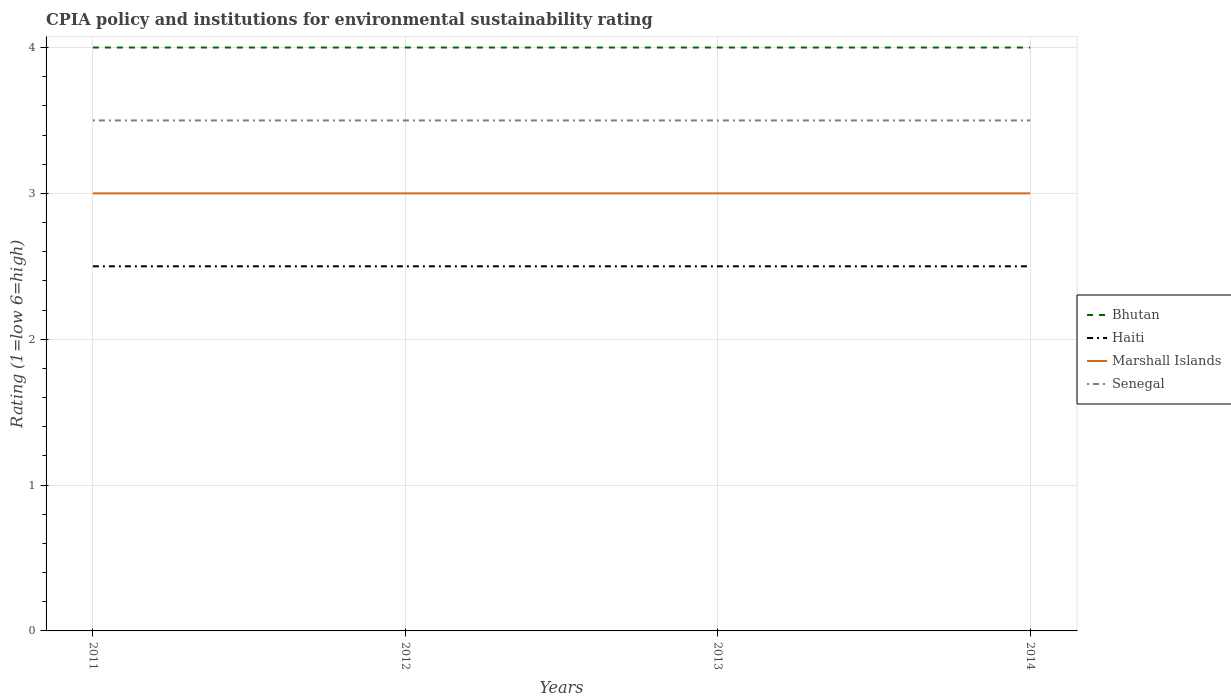How many different coloured lines are there?
Ensure brevity in your answer.  4. In which year was the CPIA rating in Haiti maximum?
Your response must be concise. 2011. What is the difference between the highest and the second highest CPIA rating in Marshall Islands?
Offer a very short reply. 0. What is the difference between two consecutive major ticks on the Y-axis?
Offer a terse response. 1. Does the graph contain any zero values?
Make the answer very short. No. Where does the legend appear in the graph?
Ensure brevity in your answer.  Center right. How many legend labels are there?
Offer a terse response. 4. How are the legend labels stacked?
Provide a short and direct response. Vertical. What is the title of the graph?
Provide a succinct answer. CPIA policy and institutions for environmental sustainability rating. Does "United States" appear as one of the legend labels in the graph?
Ensure brevity in your answer.  No. What is the label or title of the X-axis?
Your response must be concise. Years. What is the label or title of the Y-axis?
Offer a very short reply. Rating (1=low 6=high). What is the Rating (1=low 6=high) in Haiti in 2011?
Keep it short and to the point. 2.5. What is the Rating (1=low 6=high) of Senegal in 2011?
Your answer should be very brief. 3.5. What is the Rating (1=low 6=high) of Marshall Islands in 2012?
Your response must be concise. 3. What is the Rating (1=low 6=high) in Bhutan in 2014?
Keep it short and to the point. 4. What is the Rating (1=low 6=high) in Haiti in 2014?
Keep it short and to the point. 2.5. What is the Rating (1=low 6=high) of Marshall Islands in 2014?
Offer a terse response. 3. Across all years, what is the minimum Rating (1=low 6=high) in Bhutan?
Your response must be concise. 4. Across all years, what is the minimum Rating (1=low 6=high) in Haiti?
Give a very brief answer. 2.5. Across all years, what is the minimum Rating (1=low 6=high) in Senegal?
Provide a short and direct response. 3.5. What is the total Rating (1=low 6=high) in Bhutan in the graph?
Offer a very short reply. 16. What is the total Rating (1=low 6=high) of Haiti in the graph?
Your answer should be very brief. 10. What is the difference between the Rating (1=low 6=high) in Bhutan in 2011 and that in 2012?
Keep it short and to the point. 0. What is the difference between the Rating (1=low 6=high) of Haiti in 2011 and that in 2012?
Offer a very short reply. 0. What is the difference between the Rating (1=low 6=high) of Marshall Islands in 2011 and that in 2012?
Ensure brevity in your answer.  0. What is the difference between the Rating (1=low 6=high) of Senegal in 2011 and that in 2012?
Your response must be concise. 0. What is the difference between the Rating (1=low 6=high) of Haiti in 2011 and that in 2013?
Your answer should be very brief. 0. What is the difference between the Rating (1=low 6=high) of Bhutan in 2011 and that in 2014?
Ensure brevity in your answer.  0. What is the difference between the Rating (1=low 6=high) in Marshall Islands in 2011 and that in 2014?
Give a very brief answer. 0. What is the difference between the Rating (1=low 6=high) in Marshall Islands in 2012 and that in 2013?
Keep it short and to the point. 0. What is the difference between the Rating (1=low 6=high) in Marshall Islands in 2012 and that in 2014?
Your response must be concise. 0. What is the difference between the Rating (1=low 6=high) of Senegal in 2012 and that in 2014?
Provide a short and direct response. 0. What is the difference between the Rating (1=low 6=high) of Bhutan in 2013 and that in 2014?
Your answer should be very brief. 0. What is the difference between the Rating (1=low 6=high) of Bhutan in 2011 and the Rating (1=low 6=high) of Haiti in 2012?
Make the answer very short. 1.5. What is the difference between the Rating (1=low 6=high) of Haiti in 2011 and the Rating (1=low 6=high) of Marshall Islands in 2012?
Keep it short and to the point. -0.5. What is the difference between the Rating (1=low 6=high) of Marshall Islands in 2011 and the Rating (1=low 6=high) of Senegal in 2012?
Provide a short and direct response. -0.5. What is the difference between the Rating (1=low 6=high) of Bhutan in 2011 and the Rating (1=low 6=high) of Marshall Islands in 2013?
Your response must be concise. 1. What is the difference between the Rating (1=low 6=high) in Haiti in 2011 and the Rating (1=low 6=high) in Marshall Islands in 2013?
Your answer should be compact. -0.5. What is the difference between the Rating (1=low 6=high) in Bhutan in 2011 and the Rating (1=low 6=high) in Haiti in 2014?
Offer a very short reply. 1.5. What is the difference between the Rating (1=low 6=high) of Bhutan in 2011 and the Rating (1=low 6=high) of Marshall Islands in 2014?
Your answer should be very brief. 1. What is the difference between the Rating (1=low 6=high) in Bhutan in 2011 and the Rating (1=low 6=high) in Senegal in 2014?
Provide a short and direct response. 0.5. What is the difference between the Rating (1=low 6=high) in Haiti in 2011 and the Rating (1=low 6=high) in Senegal in 2014?
Offer a very short reply. -1. What is the difference between the Rating (1=low 6=high) in Bhutan in 2012 and the Rating (1=low 6=high) in Senegal in 2013?
Offer a very short reply. 0.5. What is the difference between the Rating (1=low 6=high) of Marshall Islands in 2012 and the Rating (1=low 6=high) of Senegal in 2013?
Keep it short and to the point. -0.5. What is the difference between the Rating (1=low 6=high) in Bhutan in 2012 and the Rating (1=low 6=high) in Haiti in 2014?
Offer a terse response. 1.5. What is the difference between the Rating (1=low 6=high) of Bhutan in 2012 and the Rating (1=low 6=high) of Marshall Islands in 2014?
Ensure brevity in your answer.  1. What is the difference between the Rating (1=low 6=high) in Bhutan in 2012 and the Rating (1=low 6=high) in Senegal in 2014?
Ensure brevity in your answer.  0.5. What is the difference between the Rating (1=low 6=high) in Haiti in 2012 and the Rating (1=low 6=high) in Marshall Islands in 2014?
Your answer should be compact. -0.5. What is the difference between the Rating (1=low 6=high) in Haiti in 2012 and the Rating (1=low 6=high) in Senegal in 2014?
Your answer should be compact. -1. What is the difference between the Rating (1=low 6=high) in Marshall Islands in 2012 and the Rating (1=low 6=high) in Senegal in 2014?
Your answer should be compact. -0.5. What is the difference between the Rating (1=low 6=high) in Bhutan in 2013 and the Rating (1=low 6=high) in Haiti in 2014?
Provide a short and direct response. 1.5. What is the difference between the Rating (1=low 6=high) in Haiti in 2013 and the Rating (1=low 6=high) in Marshall Islands in 2014?
Provide a short and direct response. -0.5. What is the difference between the Rating (1=low 6=high) of Haiti in 2013 and the Rating (1=low 6=high) of Senegal in 2014?
Provide a short and direct response. -1. What is the difference between the Rating (1=low 6=high) in Marshall Islands in 2013 and the Rating (1=low 6=high) in Senegal in 2014?
Give a very brief answer. -0.5. What is the average Rating (1=low 6=high) of Marshall Islands per year?
Provide a succinct answer. 3. What is the average Rating (1=low 6=high) in Senegal per year?
Offer a terse response. 3.5. In the year 2011, what is the difference between the Rating (1=low 6=high) in Bhutan and Rating (1=low 6=high) in Haiti?
Your answer should be compact. 1.5. In the year 2011, what is the difference between the Rating (1=low 6=high) in Haiti and Rating (1=low 6=high) in Senegal?
Provide a short and direct response. -1. In the year 2011, what is the difference between the Rating (1=low 6=high) in Marshall Islands and Rating (1=low 6=high) in Senegal?
Your answer should be very brief. -0.5. In the year 2012, what is the difference between the Rating (1=low 6=high) in Bhutan and Rating (1=low 6=high) in Haiti?
Keep it short and to the point. 1.5. In the year 2012, what is the difference between the Rating (1=low 6=high) of Haiti and Rating (1=low 6=high) of Marshall Islands?
Offer a terse response. -0.5. In the year 2012, what is the difference between the Rating (1=low 6=high) of Marshall Islands and Rating (1=low 6=high) of Senegal?
Offer a very short reply. -0.5. In the year 2013, what is the difference between the Rating (1=low 6=high) of Bhutan and Rating (1=low 6=high) of Haiti?
Provide a succinct answer. 1.5. In the year 2013, what is the difference between the Rating (1=low 6=high) of Bhutan and Rating (1=low 6=high) of Marshall Islands?
Give a very brief answer. 1. In the year 2013, what is the difference between the Rating (1=low 6=high) of Haiti and Rating (1=low 6=high) of Marshall Islands?
Your answer should be compact. -0.5. In the year 2013, what is the difference between the Rating (1=low 6=high) of Haiti and Rating (1=low 6=high) of Senegal?
Provide a short and direct response. -1. In the year 2014, what is the difference between the Rating (1=low 6=high) in Bhutan and Rating (1=low 6=high) in Haiti?
Your answer should be compact. 1.5. In the year 2014, what is the difference between the Rating (1=low 6=high) of Bhutan and Rating (1=low 6=high) of Senegal?
Keep it short and to the point. 0.5. What is the ratio of the Rating (1=low 6=high) in Senegal in 2011 to that in 2012?
Offer a very short reply. 1. What is the ratio of the Rating (1=low 6=high) of Haiti in 2011 to that in 2014?
Offer a terse response. 1. What is the ratio of the Rating (1=low 6=high) in Marshall Islands in 2011 to that in 2014?
Offer a terse response. 1. What is the ratio of the Rating (1=low 6=high) of Haiti in 2012 to that in 2013?
Ensure brevity in your answer.  1. What is the ratio of the Rating (1=low 6=high) in Bhutan in 2012 to that in 2014?
Provide a short and direct response. 1. What is the ratio of the Rating (1=low 6=high) of Haiti in 2012 to that in 2014?
Keep it short and to the point. 1. What is the ratio of the Rating (1=low 6=high) in Bhutan in 2013 to that in 2014?
Your answer should be compact. 1. What is the ratio of the Rating (1=low 6=high) of Senegal in 2013 to that in 2014?
Offer a terse response. 1. What is the difference between the highest and the second highest Rating (1=low 6=high) of Bhutan?
Offer a terse response. 0. What is the difference between the highest and the second highest Rating (1=low 6=high) of Marshall Islands?
Provide a succinct answer. 0. What is the difference between the highest and the second highest Rating (1=low 6=high) of Senegal?
Make the answer very short. 0. What is the difference between the highest and the lowest Rating (1=low 6=high) of Haiti?
Your answer should be very brief. 0. What is the difference between the highest and the lowest Rating (1=low 6=high) of Senegal?
Keep it short and to the point. 0. 